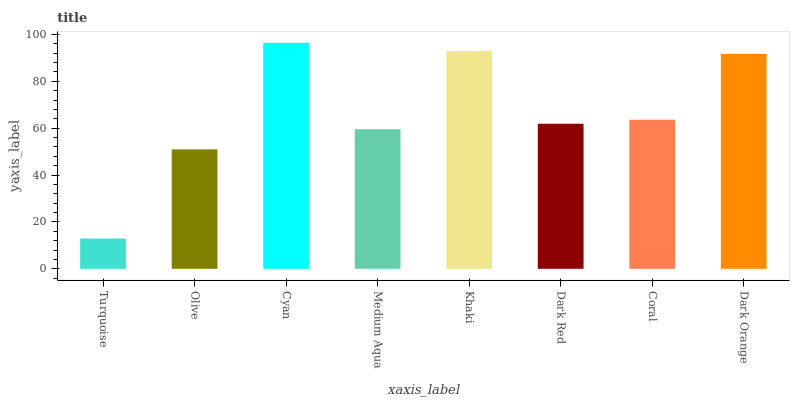Is Turquoise the minimum?
Answer yes or no. Yes. Is Cyan the maximum?
Answer yes or no. Yes. Is Olive the minimum?
Answer yes or no. No. Is Olive the maximum?
Answer yes or no. No. Is Olive greater than Turquoise?
Answer yes or no. Yes. Is Turquoise less than Olive?
Answer yes or no. Yes. Is Turquoise greater than Olive?
Answer yes or no. No. Is Olive less than Turquoise?
Answer yes or no. No. Is Coral the high median?
Answer yes or no. Yes. Is Dark Red the low median?
Answer yes or no. Yes. Is Dark Red the high median?
Answer yes or no. No. Is Turquoise the low median?
Answer yes or no. No. 